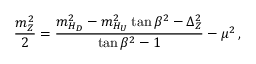Convert formula to latex. <formula><loc_0><loc_0><loc_500><loc_500>\frac { m _ { Z } ^ { 2 } } { 2 } = \frac { m _ { H _ { D } } ^ { 2 } - m _ { H _ { U } } ^ { 2 } \tan \beta ^ { 2 } - \Delta _ { Z } ^ { 2 } } { \tan \beta ^ { 2 } - 1 } - \mu ^ { 2 } \, ,</formula> 